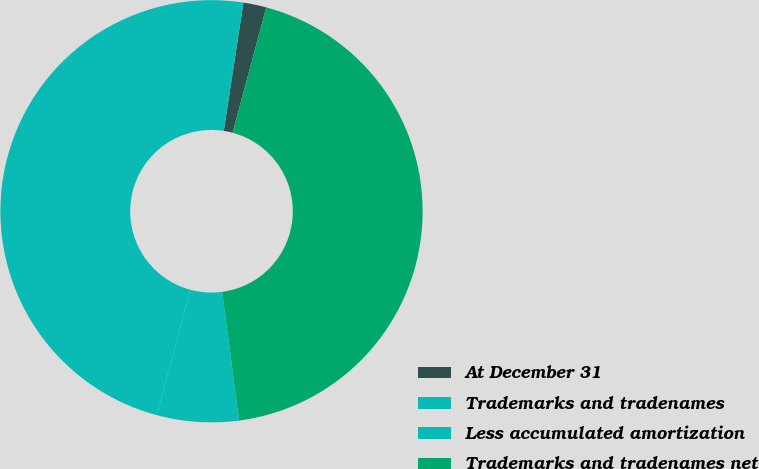<chart> <loc_0><loc_0><loc_500><loc_500><pie_chart><fcel>At December 31<fcel>Trademarks and tradenames<fcel>Less accumulated amortization<fcel>Trademarks and tradenames net<nl><fcel>1.76%<fcel>48.24%<fcel>6.27%<fcel>43.73%<nl></chart> 